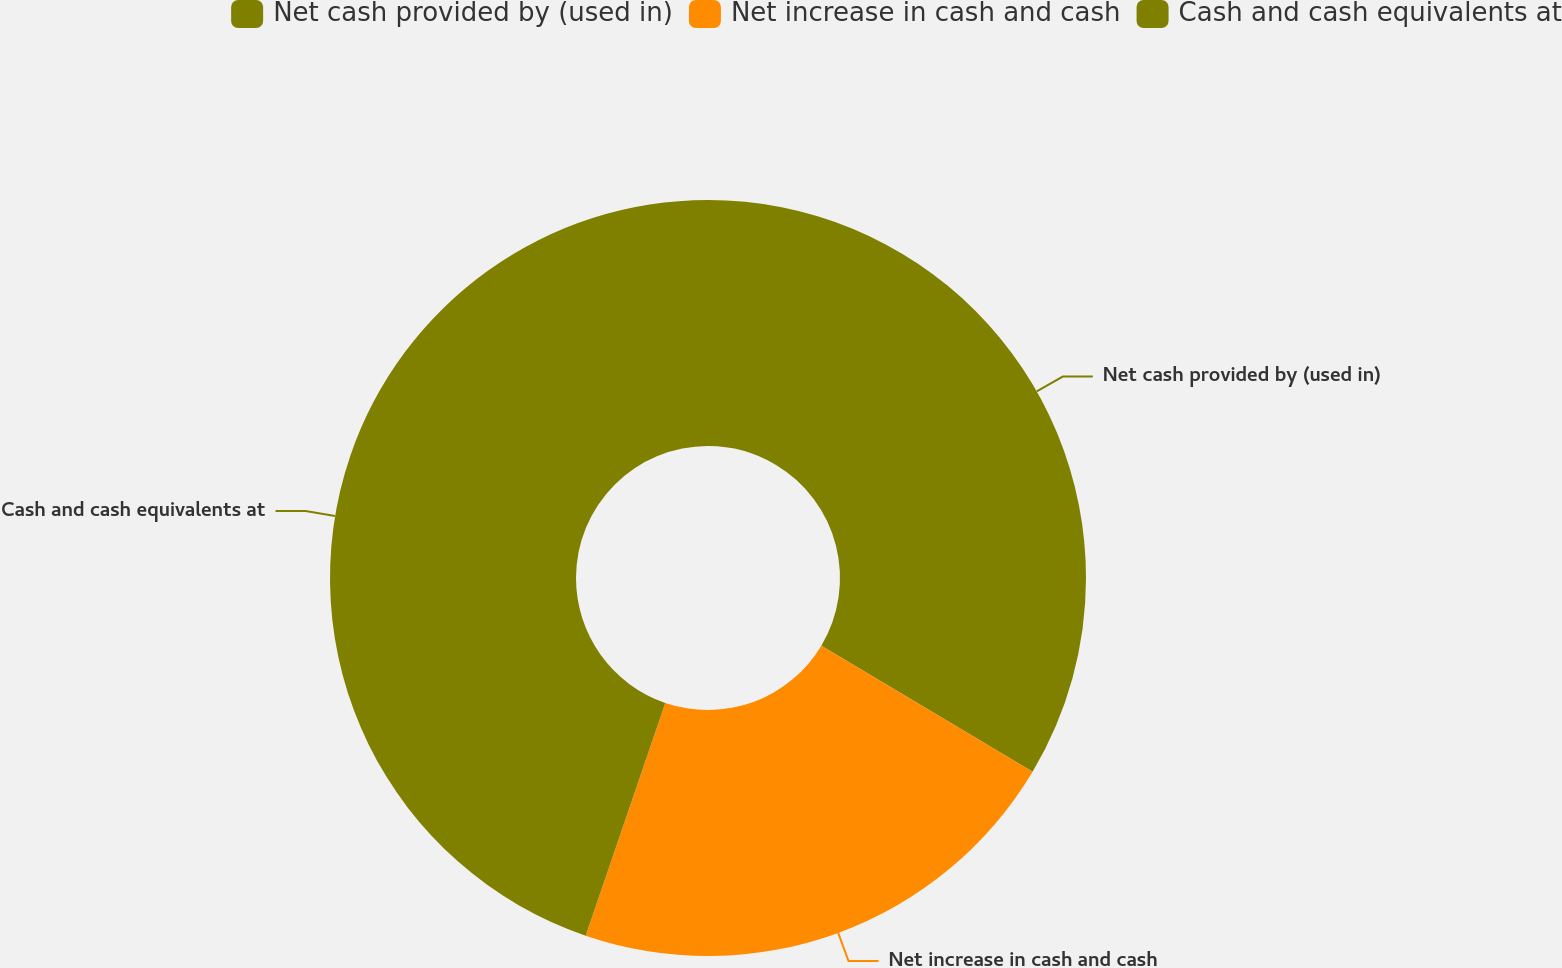<chart> <loc_0><loc_0><loc_500><loc_500><pie_chart><fcel>Net cash provided by (used in)<fcel>Net increase in cash and cash<fcel>Cash and cash equivalents at<nl><fcel>33.56%<fcel>21.68%<fcel>44.75%<nl></chart> 